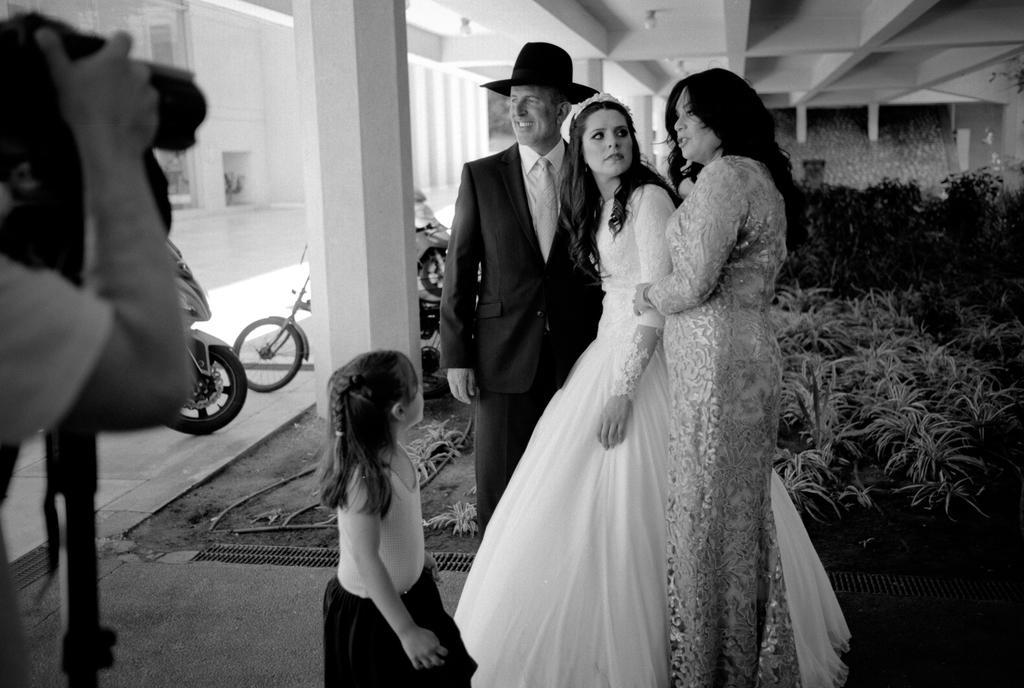How would you summarize this image in a sentence or two? In this picture there is a woman who is wearing white dress, beside her we can see another woman who is wearing silver dress. At the bottom there is a girl who is wearing t-shirt and black short, beside her we can see a man who is wearing a suit and trouser. On the left there is a man who is holding a camera. Beside the pillar we can see the bikes and bicycle. On the right we can see the plants and grass. At the top we can see the lights. 